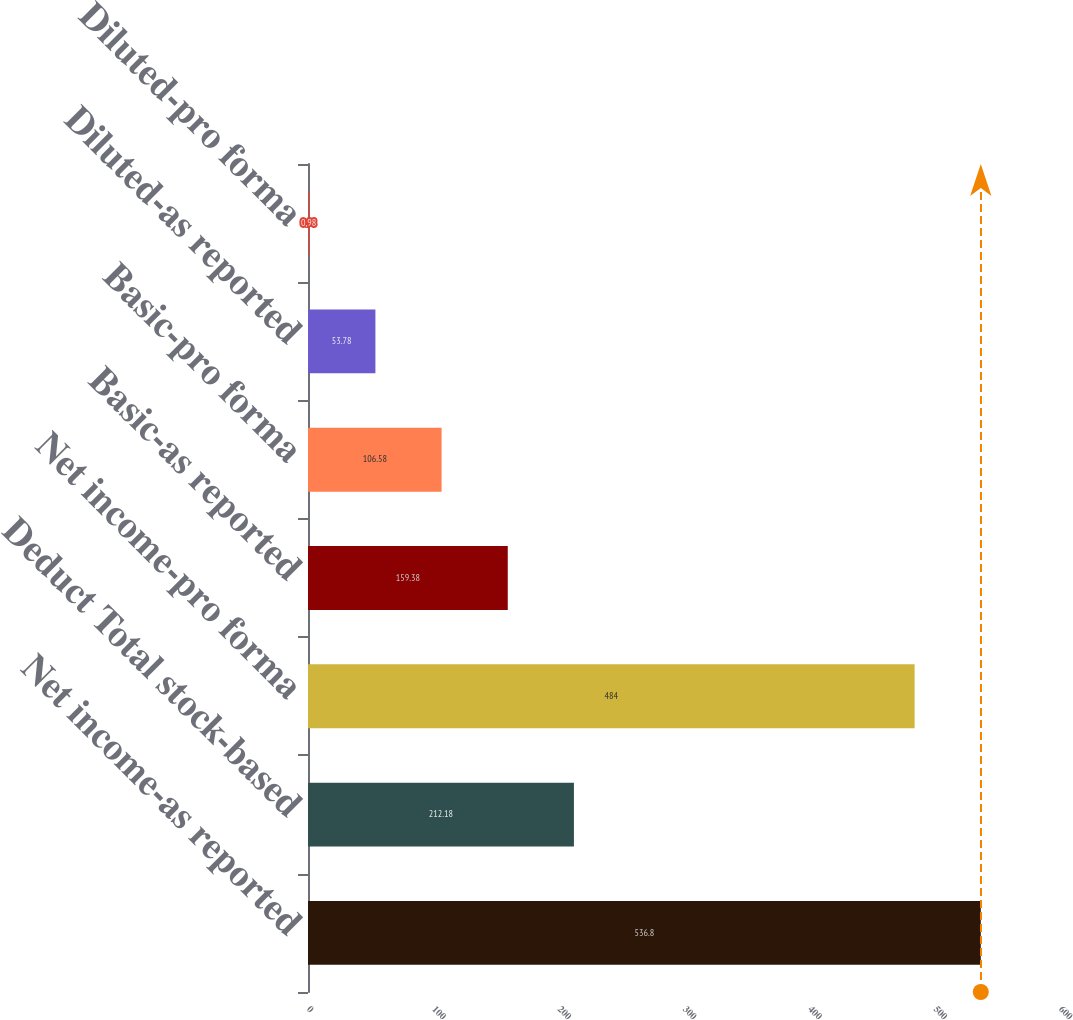Convert chart. <chart><loc_0><loc_0><loc_500><loc_500><bar_chart><fcel>Net income-as reported<fcel>Deduct Total stock-based<fcel>Net income-pro forma<fcel>Basic-as reported<fcel>Basic-pro forma<fcel>Diluted-as reported<fcel>Diluted-pro forma<nl><fcel>536.8<fcel>212.18<fcel>484<fcel>159.38<fcel>106.58<fcel>53.78<fcel>0.98<nl></chart> 